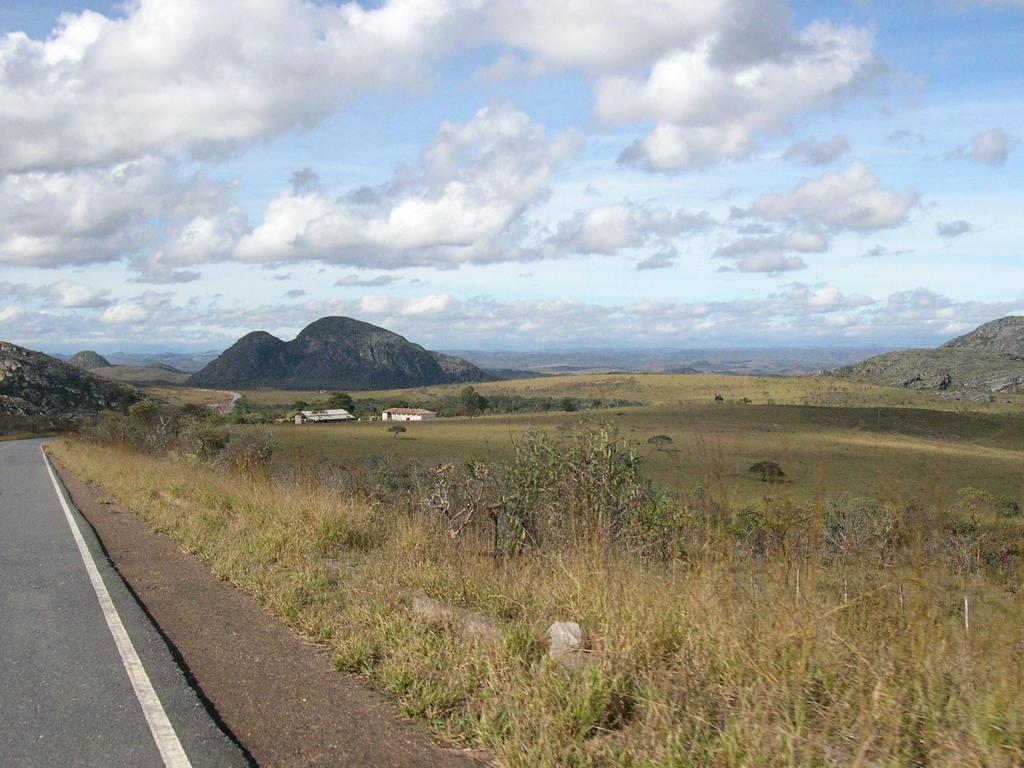Could you give a brief overview of what you see in this image? On the left there is a road. In the background there are trees,plants,grass,houses,mountains and clouds in the sky. 